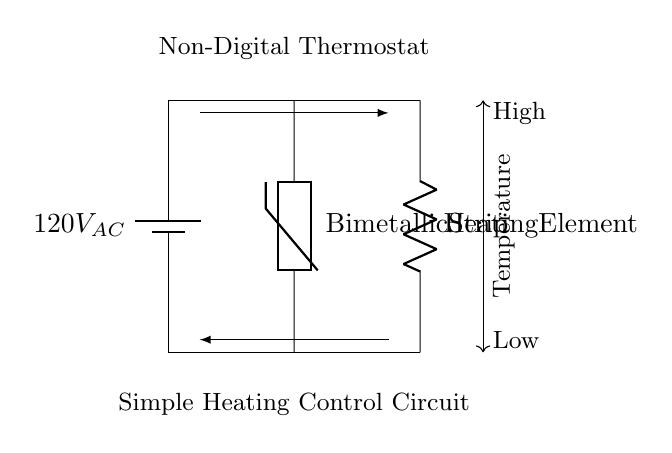What is the power supply voltage? The circuit shows a battery labeled as 120V AC, indicating the voltage supplied to the entire system.
Answer: 120V AC What type of component is the thermostat? The diagram specifies a bimetallic strip as the thermostat, which is depicted and labeled in the circuit.
Answer: Bimetallic Strip How many main components are in the circuit? The circuit includes three main components: a power supply, a thermostat, and a heating element, as identified in the diagram.
Answer: Three What does the current flow from the power supply to? The current flows from the power supply and connects to the bimetallic strip thermostat first, then to the heating element, illustrating the path through the circuit.
Answer: Bimetallic Strip What initiates the heating element when the temperature is high? In a non-digital thermostat, the bimetallic strip closes, which completes the circuit and allows current to flow through the heating element when the temperature rise is sensed.
Answer: Bimetallic Strip Which way does the current flow? The arrows in the diagram indicate the direction of current flow, showing it moves from the power supply through the thermostat to the heating element and back again.
Answer: Left to right 